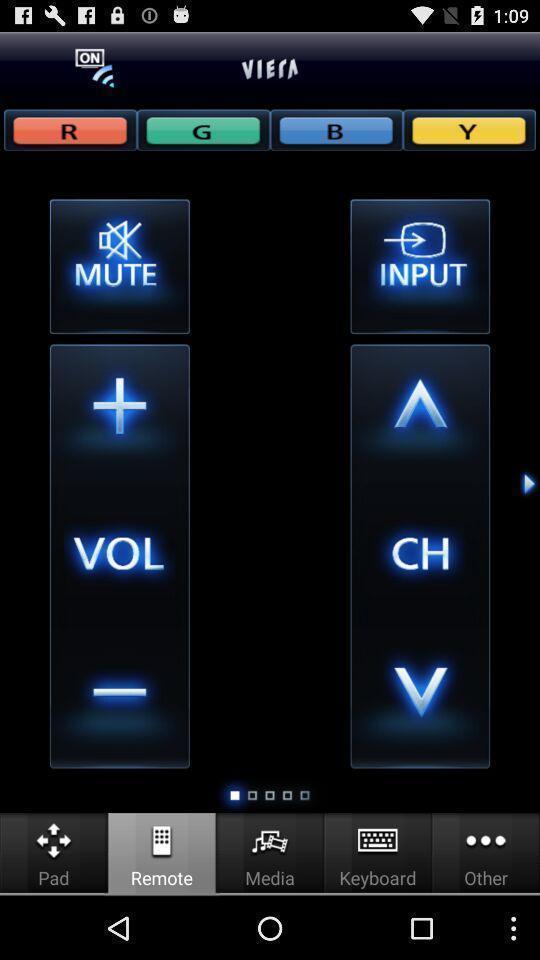Describe the visual elements of this screenshot. Remote setup and remote in tv app. 